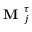<formula> <loc_0><loc_0><loc_500><loc_500>M _ { j } ^ { \tau }</formula> 